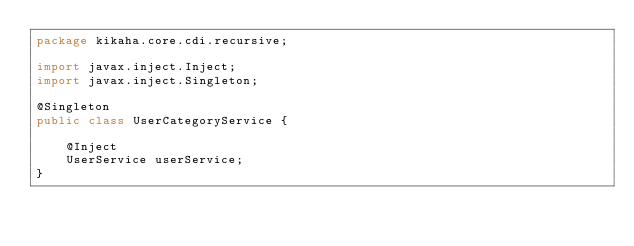<code> <loc_0><loc_0><loc_500><loc_500><_Java_>package kikaha.core.cdi.recursive;

import javax.inject.Inject;
import javax.inject.Singleton;

@Singleton
public class UserCategoryService {

	@Inject
	UserService userService;
}
</code> 